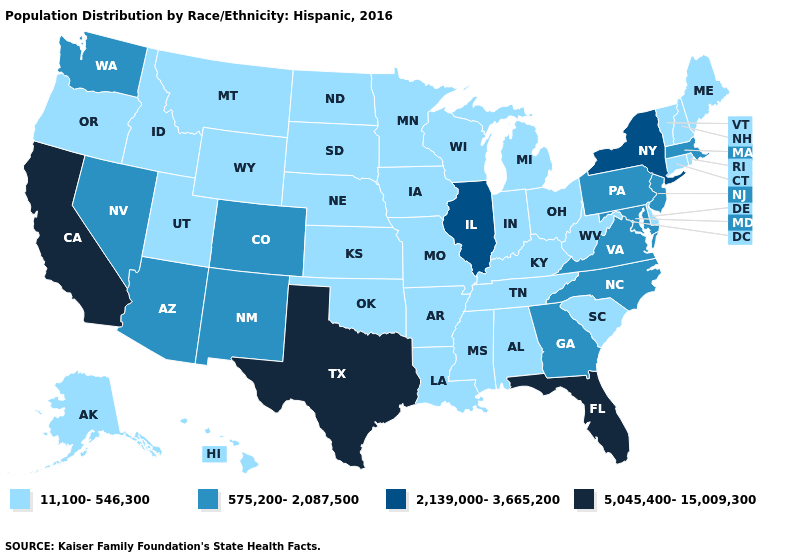Name the states that have a value in the range 575,200-2,087,500?
Answer briefly. Arizona, Colorado, Georgia, Maryland, Massachusetts, Nevada, New Jersey, New Mexico, North Carolina, Pennsylvania, Virginia, Washington. What is the value of Texas?
Quick response, please. 5,045,400-15,009,300. Among the states that border Colorado , does Arizona have the highest value?
Give a very brief answer. Yes. Name the states that have a value in the range 11,100-546,300?
Be succinct. Alabama, Alaska, Arkansas, Connecticut, Delaware, Hawaii, Idaho, Indiana, Iowa, Kansas, Kentucky, Louisiana, Maine, Michigan, Minnesota, Mississippi, Missouri, Montana, Nebraska, New Hampshire, North Dakota, Ohio, Oklahoma, Oregon, Rhode Island, South Carolina, South Dakota, Tennessee, Utah, Vermont, West Virginia, Wisconsin, Wyoming. Does Massachusetts have the highest value in the USA?
Keep it brief. No. What is the highest value in the West ?
Concise answer only. 5,045,400-15,009,300. What is the highest value in the USA?
Keep it brief. 5,045,400-15,009,300. What is the value of Nevada?
Write a very short answer. 575,200-2,087,500. Name the states that have a value in the range 11,100-546,300?
Short answer required. Alabama, Alaska, Arkansas, Connecticut, Delaware, Hawaii, Idaho, Indiana, Iowa, Kansas, Kentucky, Louisiana, Maine, Michigan, Minnesota, Mississippi, Missouri, Montana, Nebraska, New Hampshire, North Dakota, Ohio, Oklahoma, Oregon, Rhode Island, South Carolina, South Dakota, Tennessee, Utah, Vermont, West Virginia, Wisconsin, Wyoming. What is the value of Iowa?
Write a very short answer. 11,100-546,300. What is the value of Alabama?
Quick response, please. 11,100-546,300. What is the highest value in states that border North Carolina?
Quick response, please. 575,200-2,087,500. Name the states that have a value in the range 5,045,400-15,009,300?
Concise answer only. California, Florida, Texas. What is the value of Colorado?
Answer briefly. 575,200-2,087,500. What is the highest value in the USA?
Concise answer only. 5,045,400-15,009,300. 